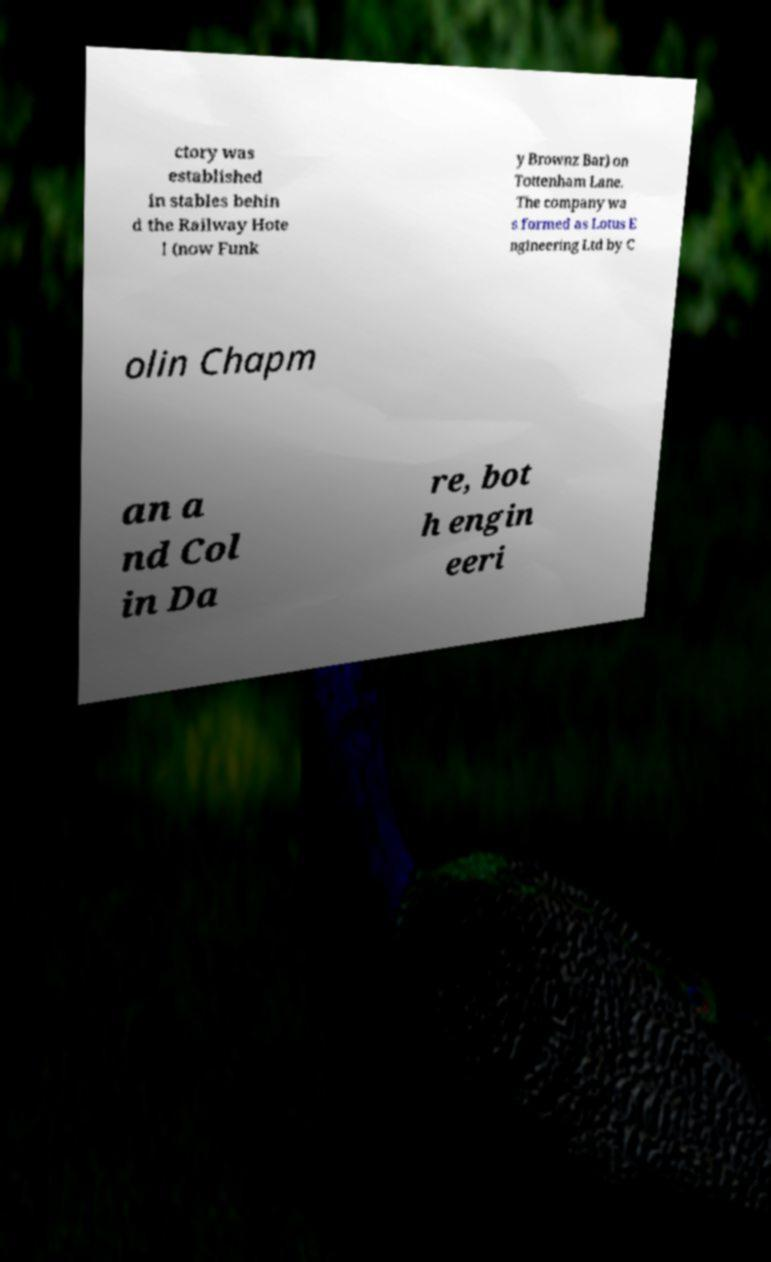Please read and relay the text visible in this image. What does it say? ctory was established in stables behin d the Railway Hote l (now Funk y Brownz Bar) on Tottenham Lane. The company wa s formed as Lotus E ngineering Ltd by C olin Chapm an a nd Col in Da re, bot h engin eeri 